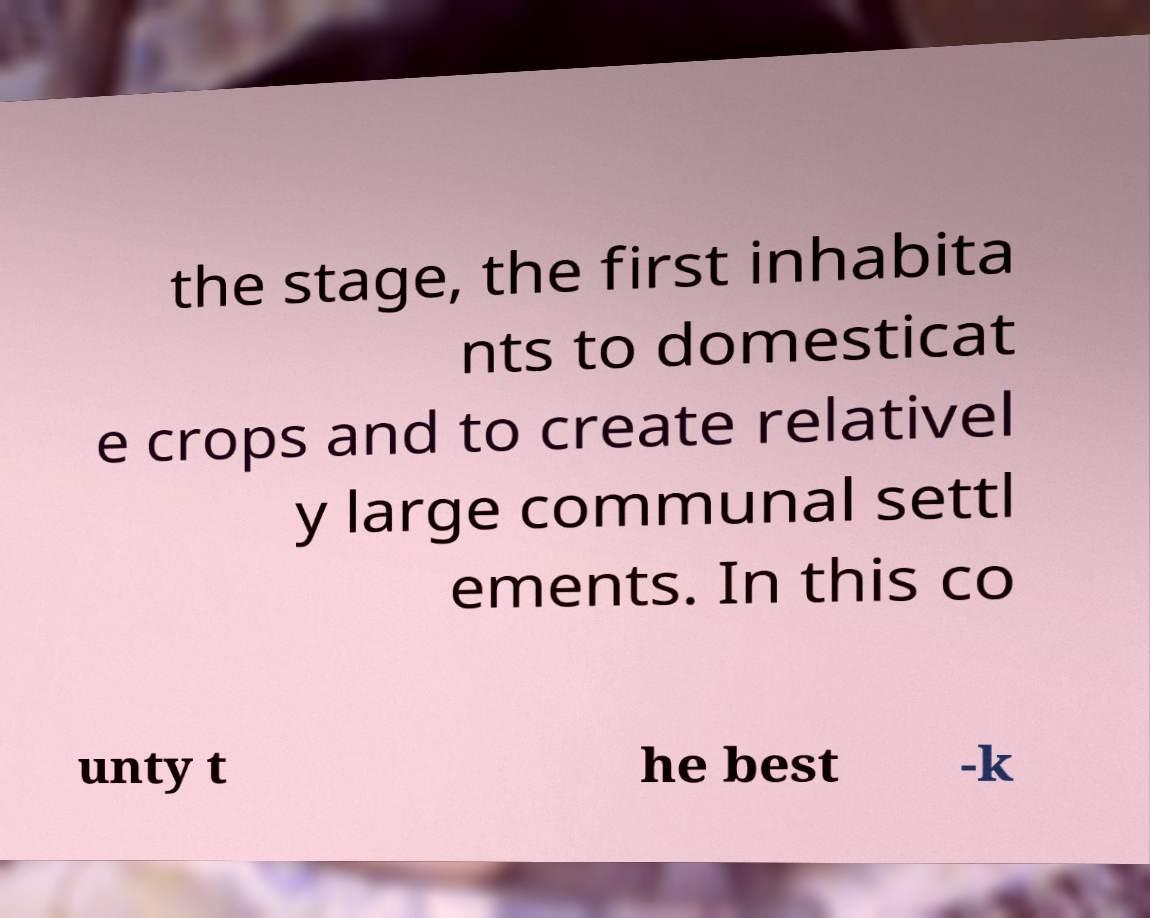What messages or text are displayed in this image? I need them in a readable, typed format. the stage, the first inhabita nts to domesticat e crops and to create relativel y large communal settl ements. In this co unty t he best -k 